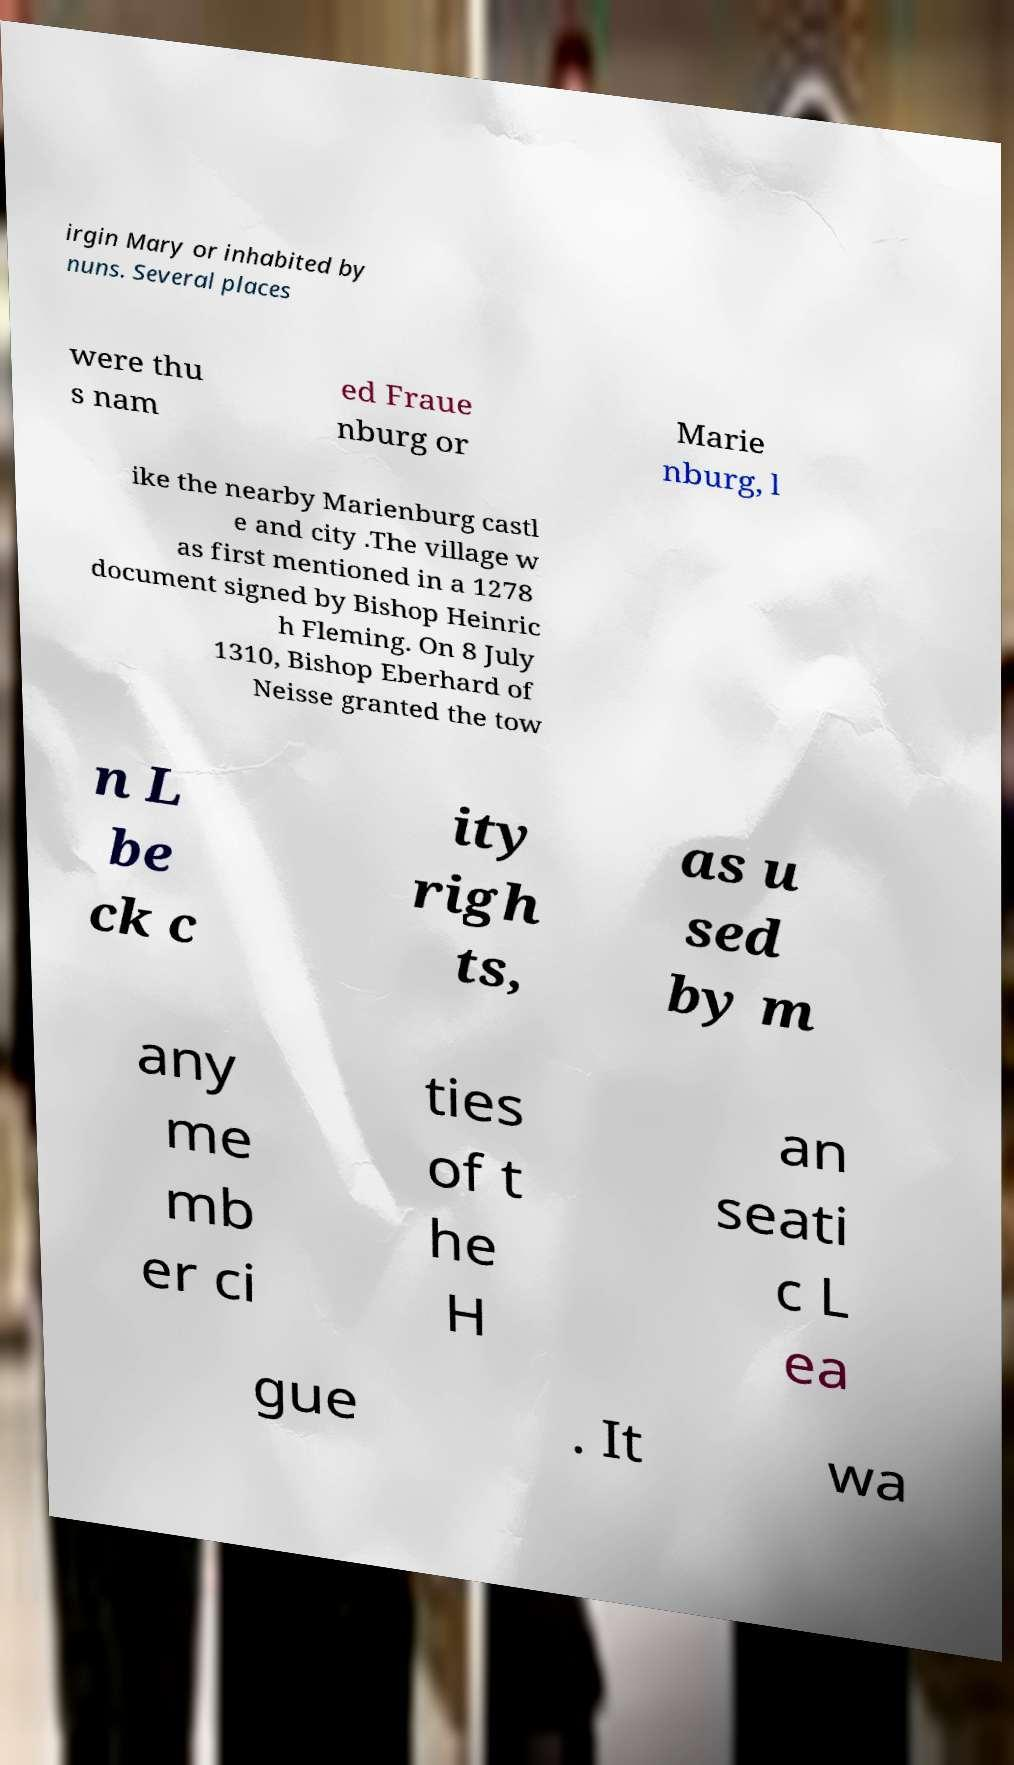Could you extract and type out the text from this image? irgin Mary or inhabited by nuns. Several places were thu s nam ed Fraue nburg or Marie nburg, l ike the nearby Marienburg castl e and city .The village w as first mentioned in a 1278 document signed by Bishop Heinric h Fleming. On 8 July 1310, Bishop Eberhard of Neisse granted the tow n L be ck c ity righ ts, as u sed by m any me mb er ci ties of t he H an seati c L ea gue . It wa 